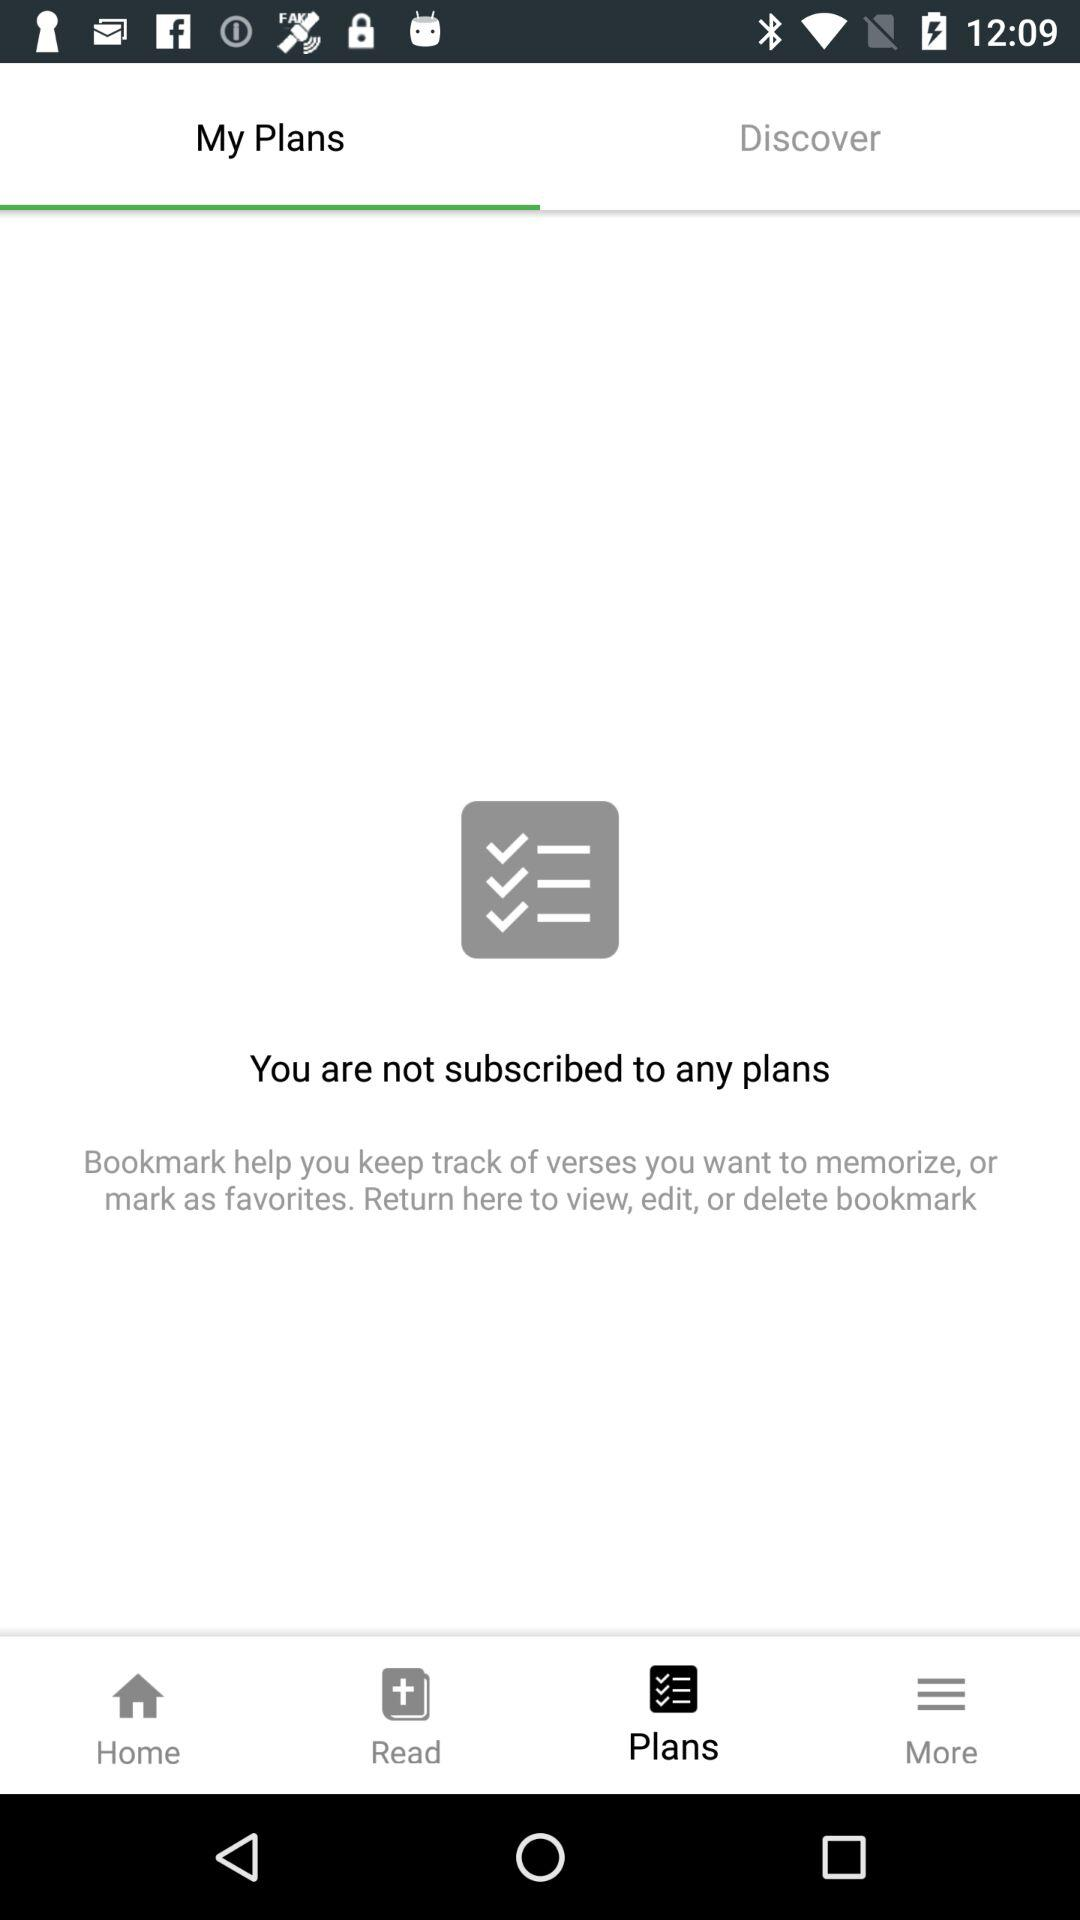What features does this app offer for managing plans? The app shown in the image seems to offer features such as bookmarking, which helps you keep track of verses you want to memorize, or mark as favorites. It likely includes the ability to view, edit, or delete these bookmarks, ensuring convenient plan management. Can I create plans or subscribe to new ones within this app? Yes, once you discover plans that resonate with your interests, you should be able to subscribe to them directly within the app, which will then be displayed under 'My Plans' for easy access. 